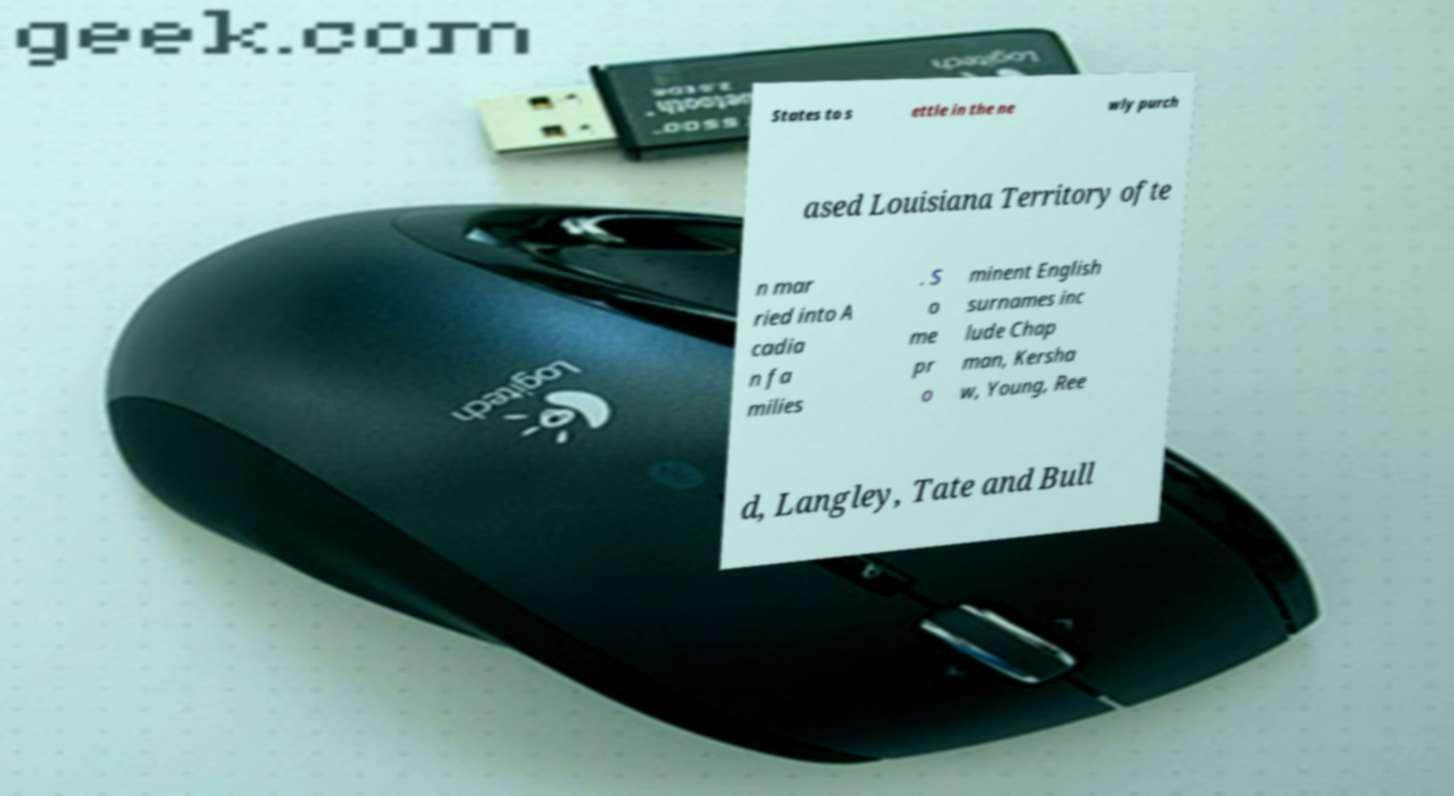Can you read and provide the text displayed in the image?This photo seems to have some interesting text. Can you extract and type it out for me? States to s ettle in the ne wly purch ased Louisiana Territory ofte n mar ried into A cadia n fa milies . S o me pr o minent English surnames inc lude Chap man, Kersha w, Young, Ree d, Langley, Tate and Bull 